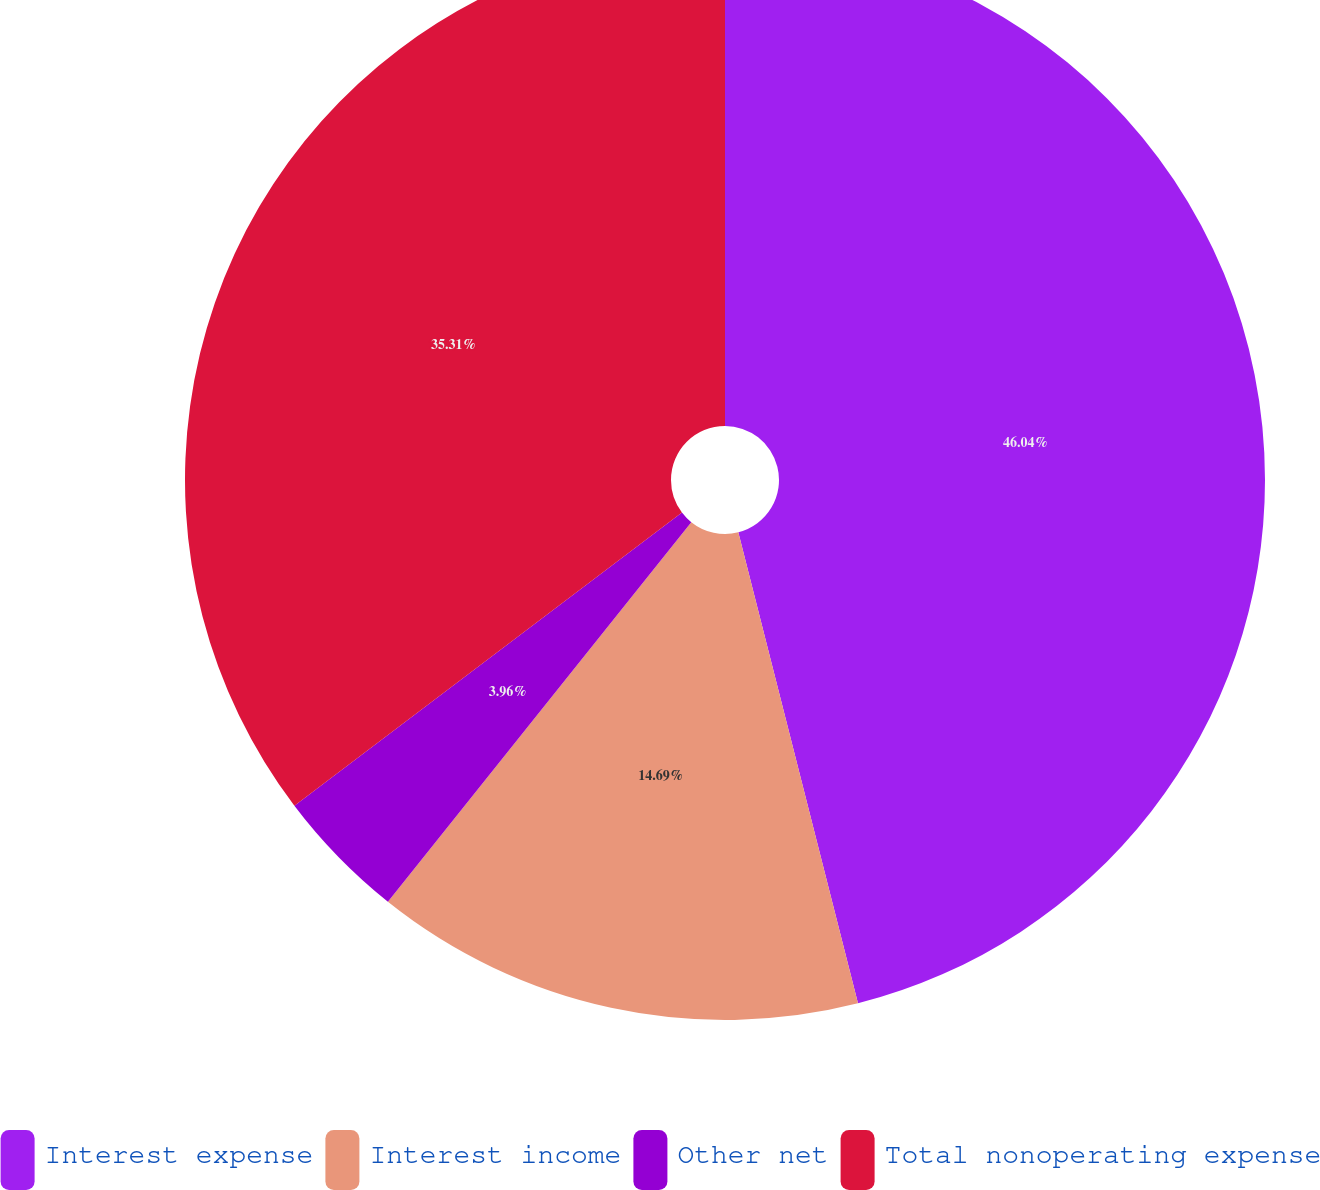Convert chart to OTSL. <chart><loc_0><loc_0><loc_500><loc_500><pie_chart><fcel>Interest expense<fcel>Interest income<fcel>Other net<fcel>Total nonoperating expense<nl><fcel>46.04%<fcel>14.69%<fcel>3.96%<fcel>35.31%<nl></chart> 